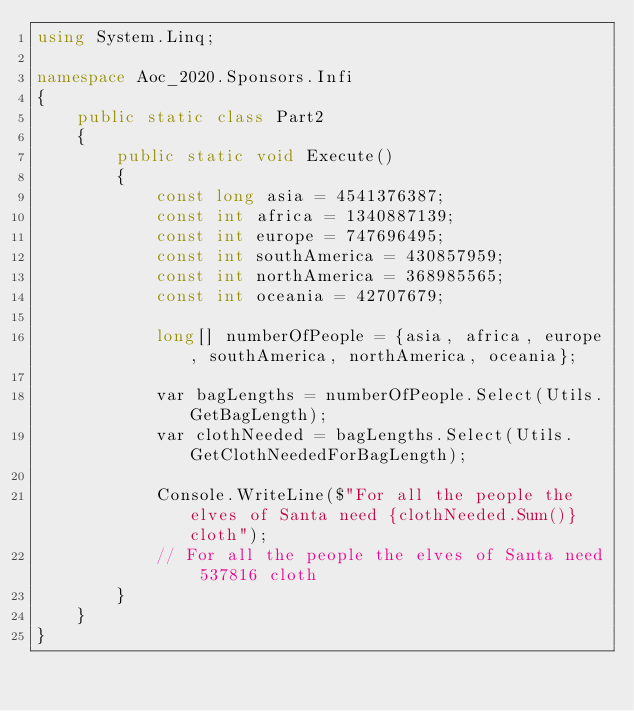<code> <loc_0><loc_0><loc_500><loc_500><_C#_>using System.Linq;

namespace Aoc_2020.Sponsors.Infi
{
    public static class Part2
    {
        public static void Execute()
        {
            const long asia = 4541376387;
            const int africa = 1340887139;
            const int europe = 747696495;
            const int southAmerica = 430857959;
            const int northAmerica = 368985565;
            const int oceania = 42707679;

            long[] numberOfPeople = {asia, africa, europe, southAmerica, northAmerica, oceania};

            var bagLengths = numberOfPeople.Select(Utils.GetBagLength);
            var clothNeeded = bagLengths.Select(Utils.GetClothNeededForBagLength);

            Console.WriteLine($"For all the people the elves of Santa need {clothNeeded.Sum()} cloth");
            // For all the people the elves of Santa need 537816 cloth
        }
    }
}</code> 